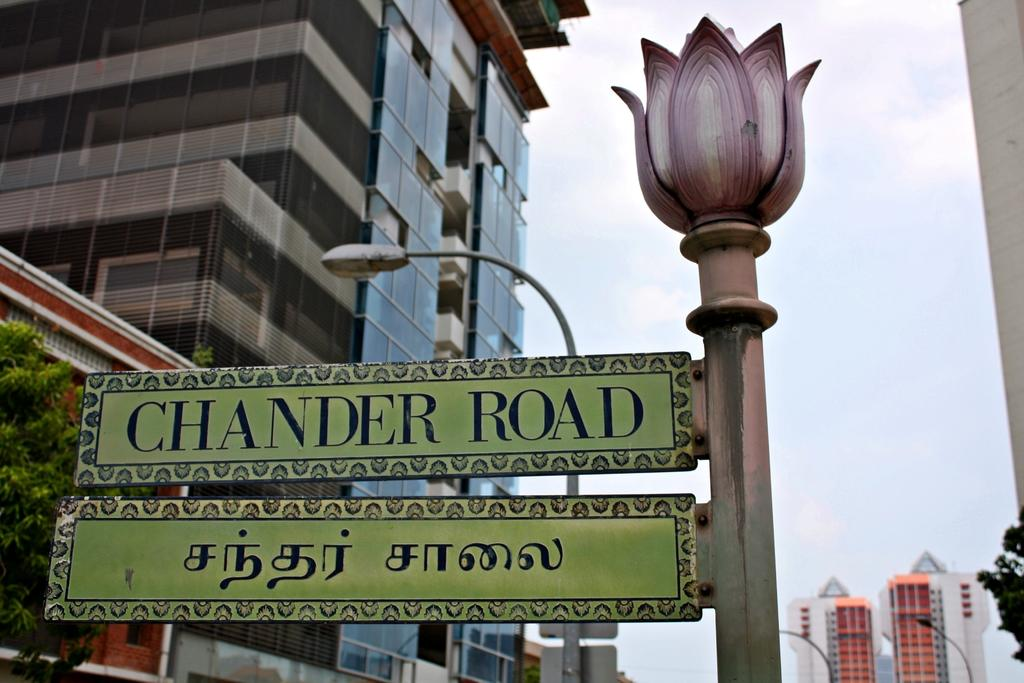What is the main object in the image? There is a pole in the image. How many boards are attached to the pole? There are 2 boards on the pole. What can be found on the boards? Words are written on the boards. What can be seen in the background of the image? There are buildings, trees, and 3 light poles in the background of the image. What part of the natural environment is visible in the image? The sky is visible in the background of the image. What is the design of the table in the image? There is no table present in the image. What is the size of the design on the table? Since there is no table in the image, we cannot determine the size of any design on it. 